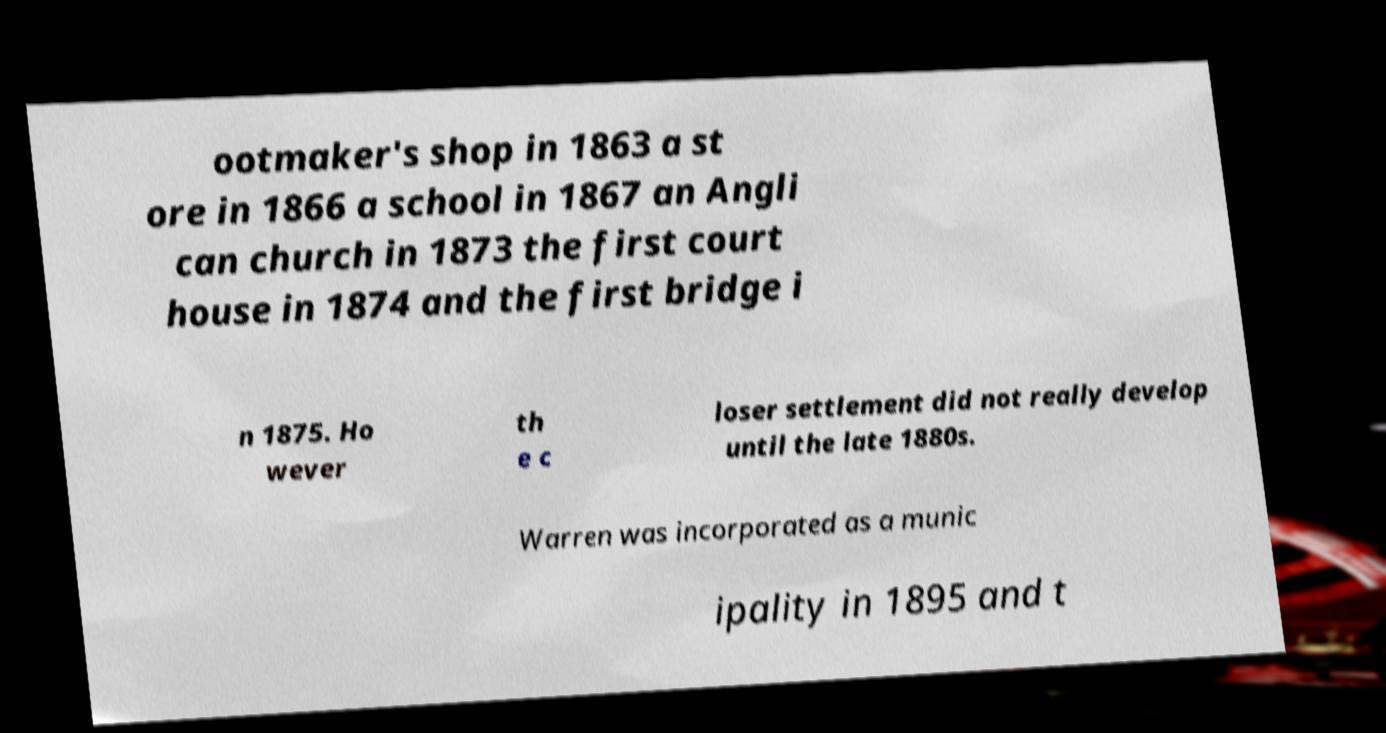What messages or text are displayed in this image? I need them in a readable, typed format. ootmaker's shop in 1863 a st ore in 1866 a school in 1867 an Angli can church in 1873 the first court house in 1874 and the first bridge i n 1875. Ho wever th e c loser settlement did not really develop until the late 1880s. Warren was incorporated as a munic ipality in 1895 and t 